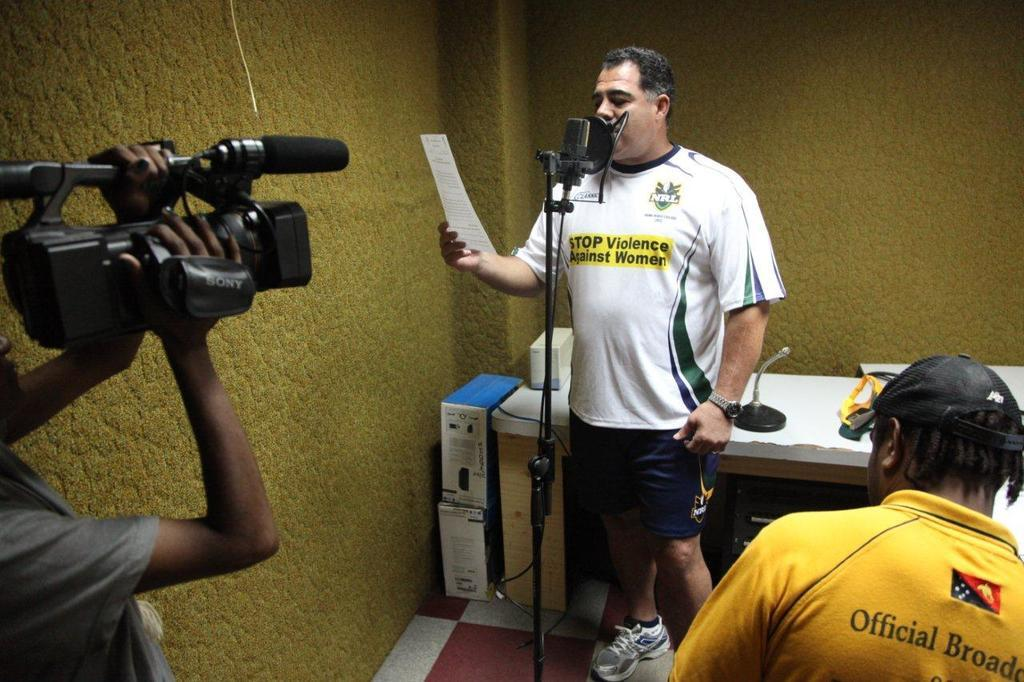<image>
Describe the image concisely. Man wearing a shirt with a yellow part that says "STOP VIOLENCE". 